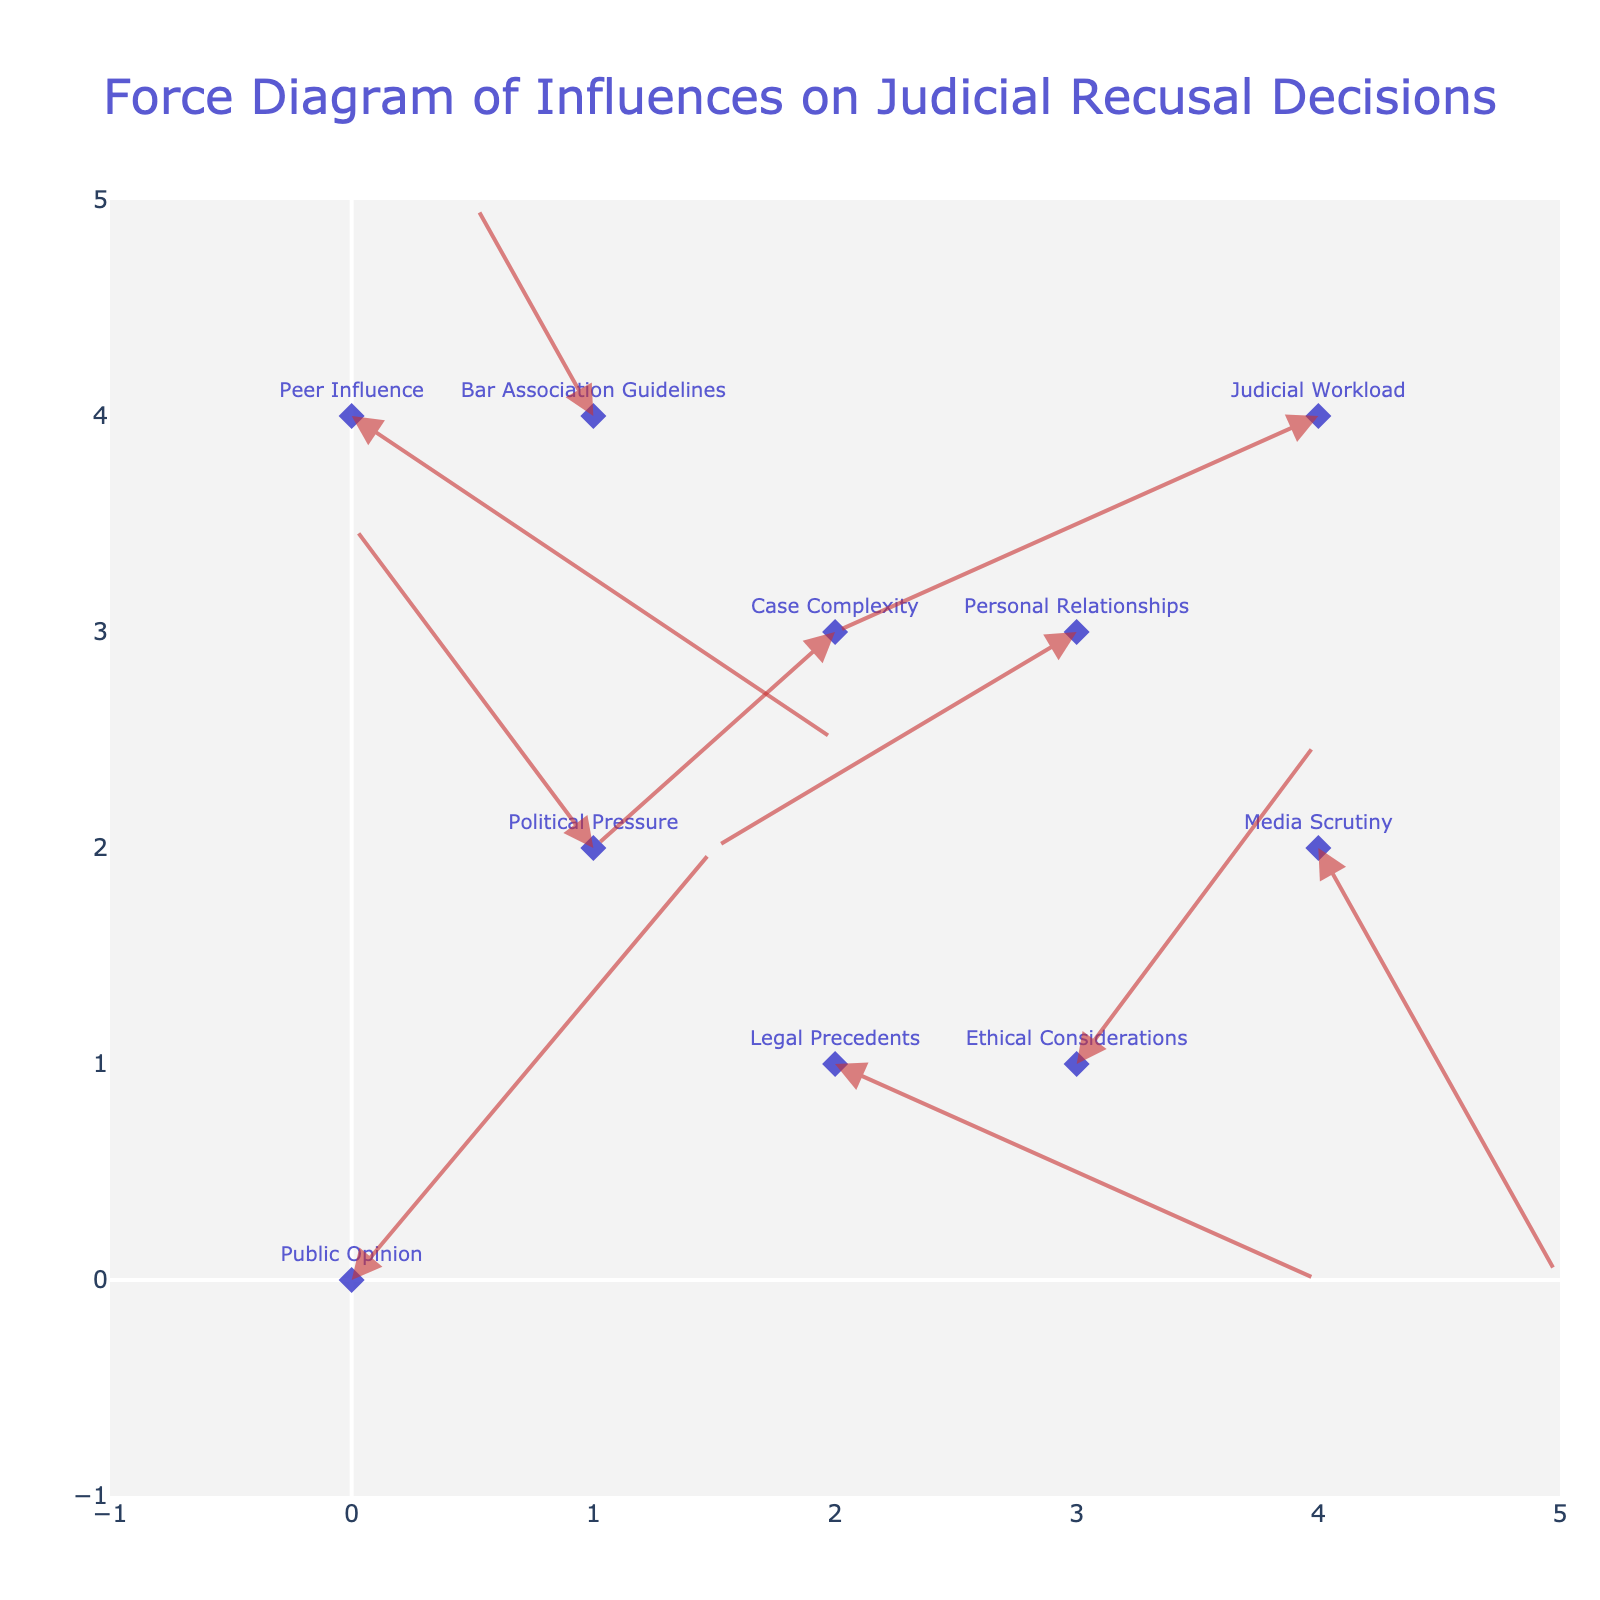What's the title of the plot? The title of the plot is displayed prominently at the top center of the figure, indicating its subject matter.
Answer: Force Diagram of Influences on Judicial Recusal Decisions How many data points are there in the plot? By counting the number of arrows and labels in the plot, we can determine the number of data points. In this case, there are 10 labeled arrows, each representing a distinct data point.
Answer: 10 Which influence has the highest positive u component? The u component represents the horizontal direction, with positive values indicating a rightward direction. Among the arrows, "Legal Precedents" has a u component of 2, which is the highest positive value.
Answer: Legal Precedents How many influences have a negative v component? The v component represents the vertical direction, with negative values indicating a downward direction. By examining the v values in the dataset, we see that "Legal Precedents," "Personal Relationships," "Media Scrutiny," "Case Complexity," "Judicial Workload," and "Peer Influence" all have negative v components.
Answer: 6 Which influence points to the bottom-left direction? An influence pointing to the bottom-left would have both negative u and v components. By examining the dataset, we find that "Judicial Workload" has u = -2 and v = -1.
Answer: Judicial Workload Compare the directions of "Public Opinion" and "Political Pressure." Which influence has a greater overall magnitude of force? To compare the magnitudes, we need to calculate the Euclidean distance for both vectors. The magnitude for "Public Opinion" is sqrt(1.5^2 + 2^2) which equals sqrt(6.25) ≈ 2.5. The magnitude for "Political Pressure" is sqrt((-1)^2 + 1.5^2) which equals sqrt(2.25 + 1) ≈ 1.8.
Answer: Public Opinion Which influence has the smallest horizontal displacement? The horizontal displacement is indicated by the u component. By examining the dataset, "Bar Association Guidelines" has a u component of -0.5, which is the smallest in magnitude.
Answer: Bar Association Guidelines What is the position of "Ethical Considerations" in the plot? By referring to the dataset, the position of "Ethical Considerations" is given by the coordinates (3, 1).
Answer: (3, 1) How does the direction of "Media Scrutiny" compare with "Case Complexity"? By looking at their u and v components, "Media Scrutiny" moves right (u = 1) and down (v = -2), while "Case Complexity" moves left (u = -1) and down (v = -1). Both move downward but in opposite horizontal directions.
Answer: Opposite directions horizontally, both move down If you consider only the influences with positive v components, how many are there and what are they? The v component indicates the vertical direction. Looking at the dataset, "Public Opinion," "Political Pressure," and "Ethical Considerations" have positive v components. Thus, there are three such influences.
Answer: 3 - Public Opinion, Political Pressure, Ethical Considerations 